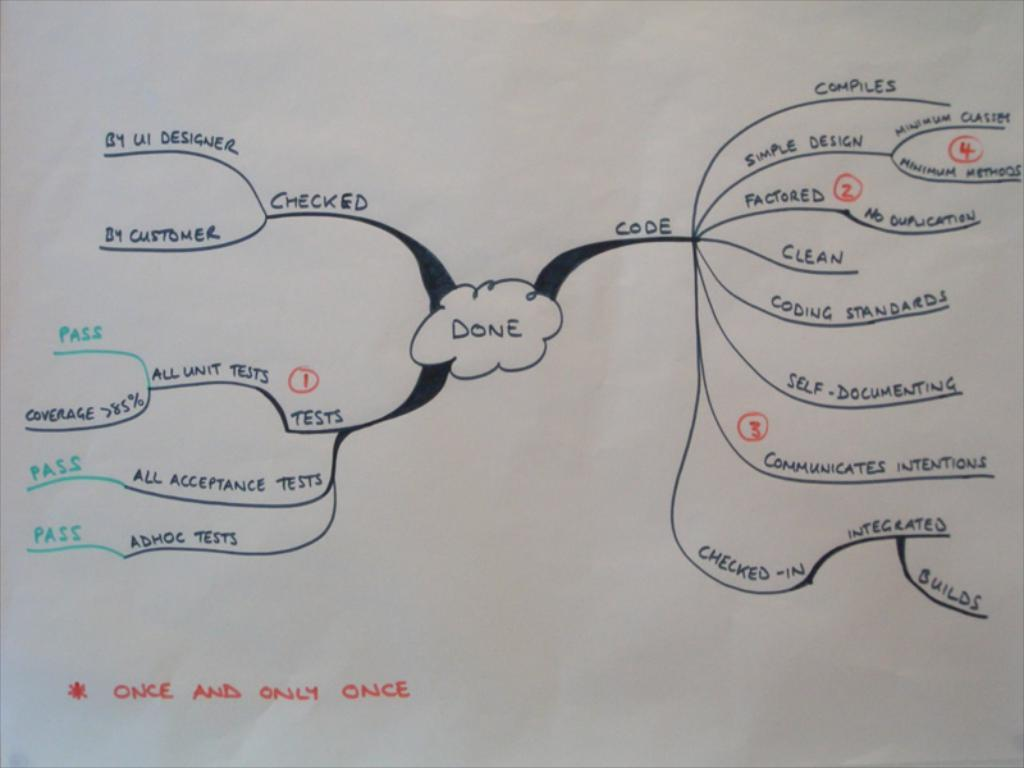<image>
Offer a succinct explanation of the picture presented. A diagram is drawn on a piece of paper, with an asterisked note stating "once and only once". 